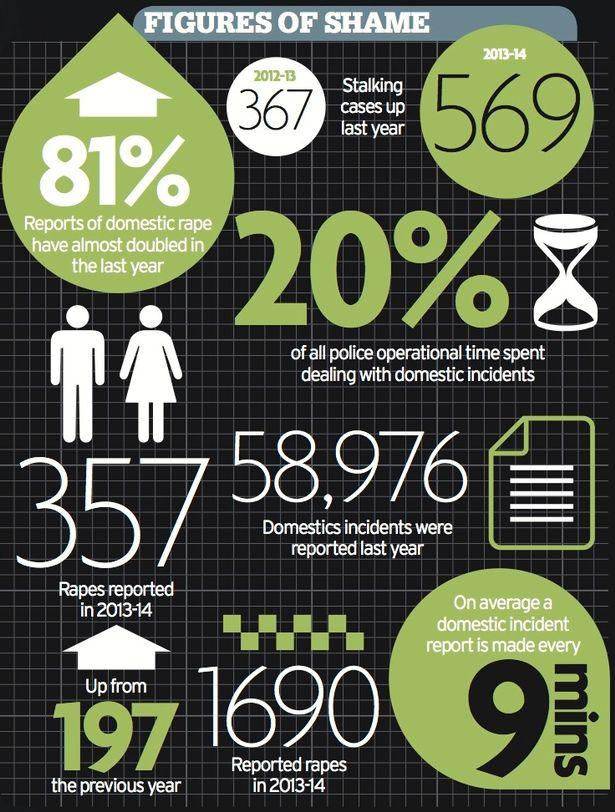Mention a couple of crucial points in this snapshot. The percentage of domestic rape incidents has increased by 81% compared to last year. The number of stalking cases increased from 2012-13 to 2013-14. An average of 10 domestic incident reports are made every 1.5 hours. The reported rape cases have increased from 2012-13 by 197 cases. According to data, approximately 80% of police operational time is spent on activities other than domestic incidents. 